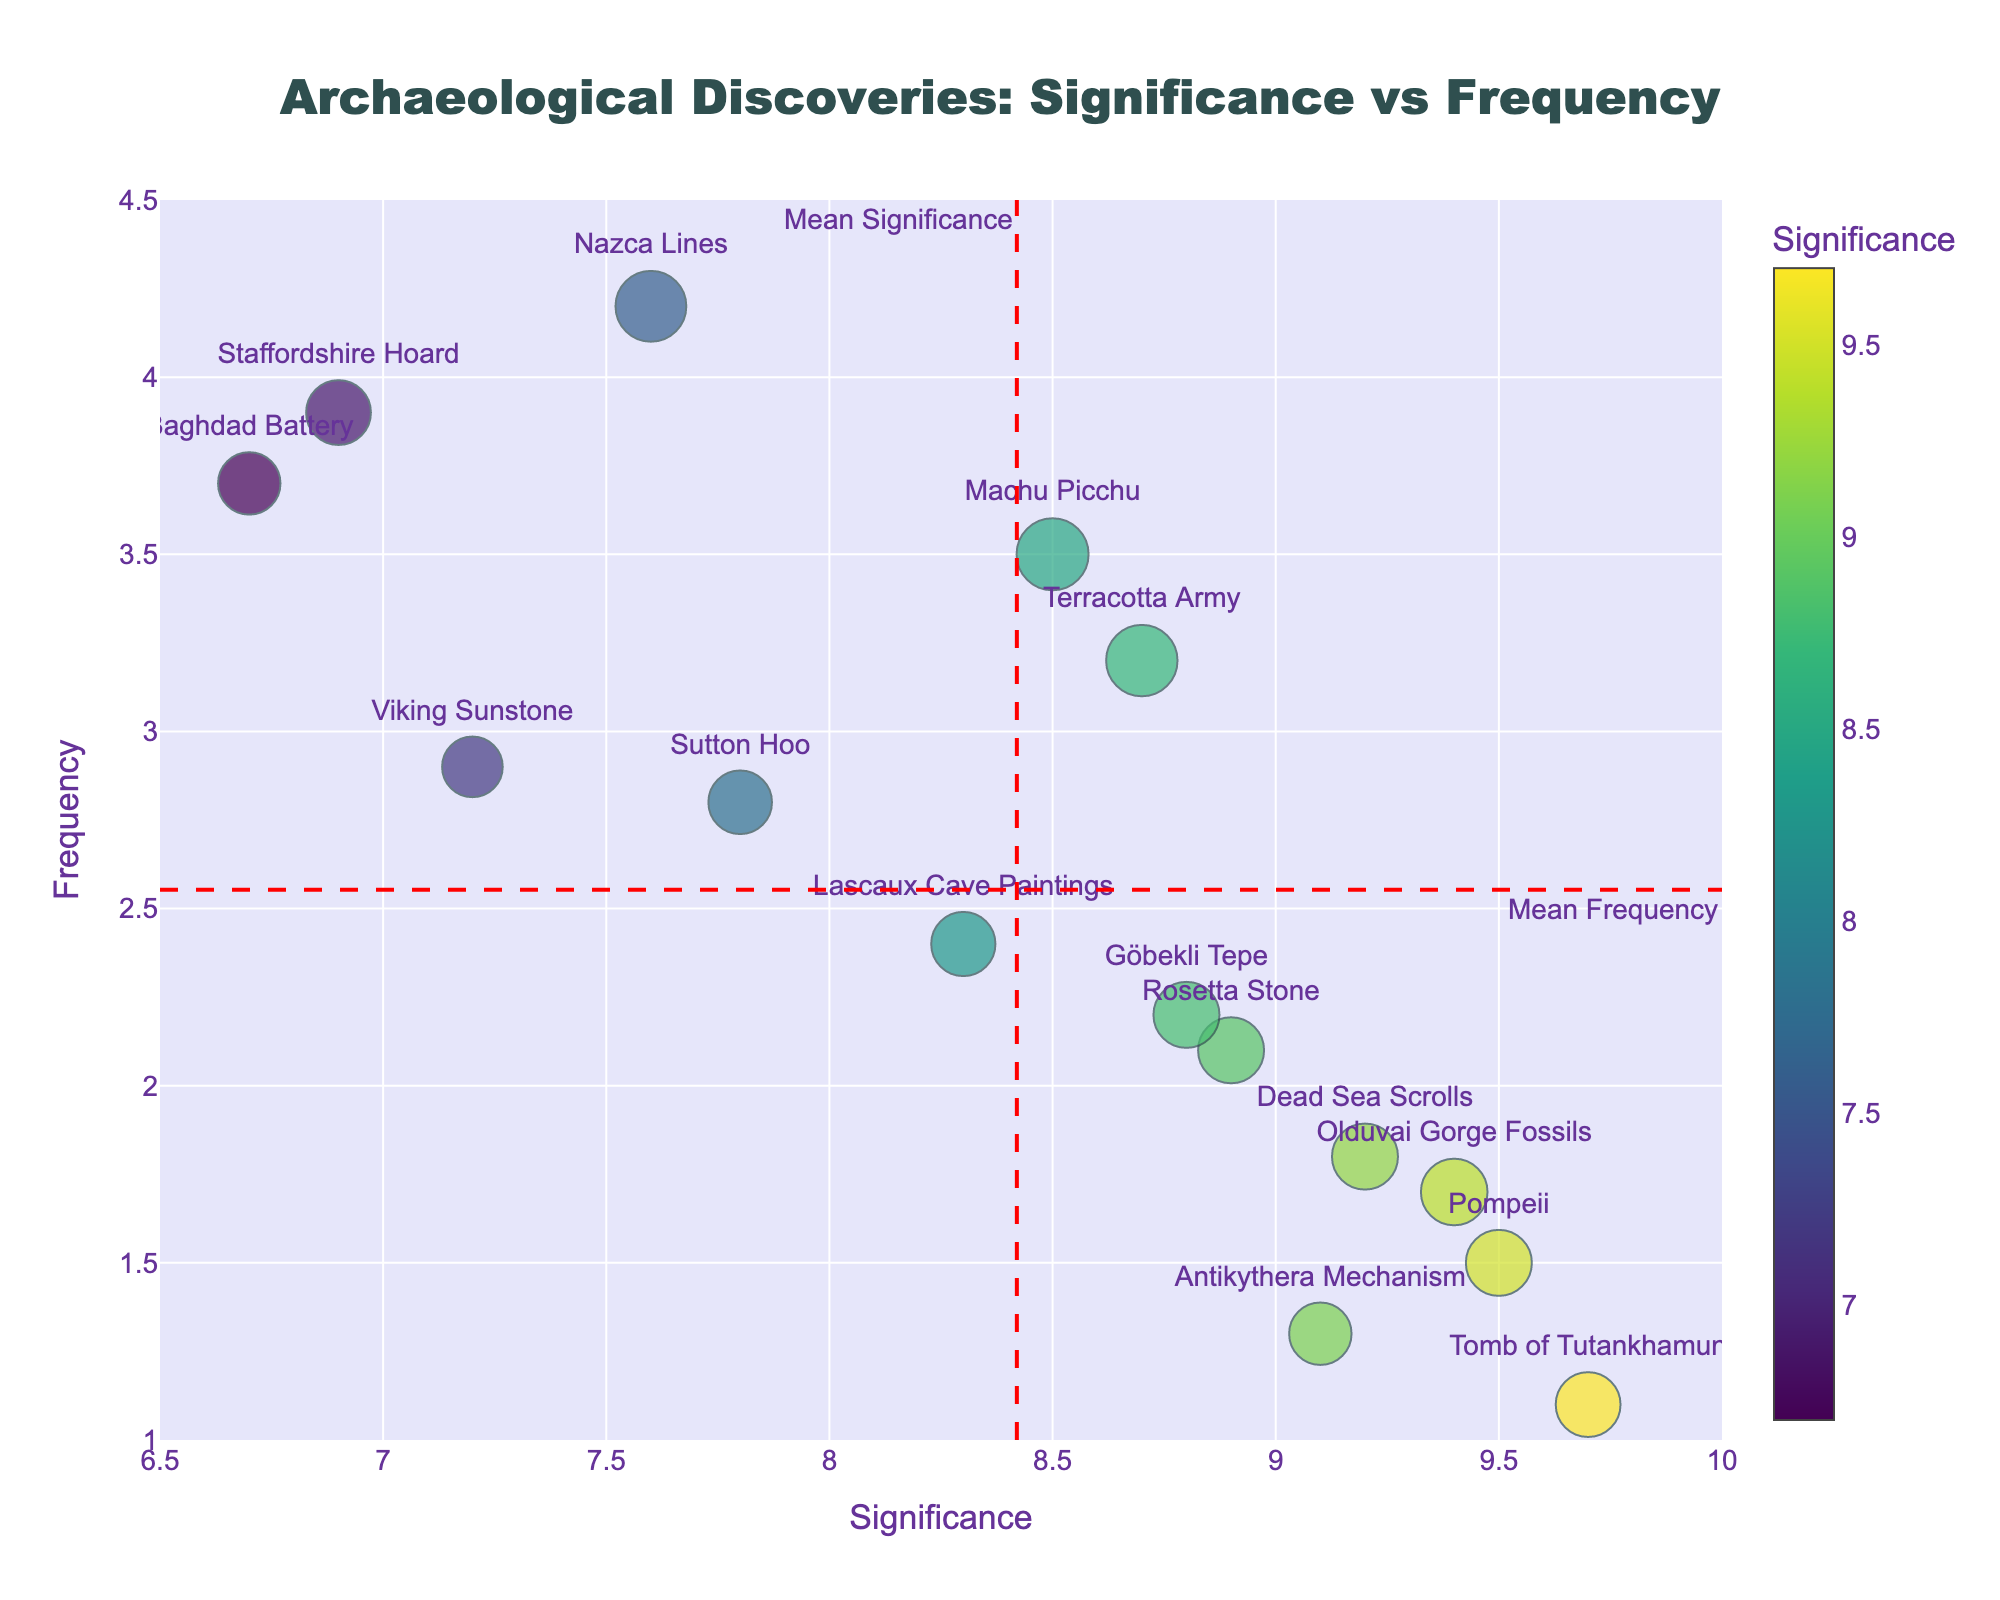What is the mean significance value across all discoveries? The mean significance value can be determined by the red vertical dashed line labeled "Mean Significance" in the plot.
Answer: 8.4 How many discoveries have a frequency higher than the mean frequency? To answer this, count the number of data points that are above the red horizontal dashed line labeled "Mean Frequency" on the plot.
Answer: 6 Which discovery has the highest significance value? By looking at the plot for the data point that is furthest to the right along the x-axis (Significance), we can see that it is the Tomb of Tutankhamun.
Answer: Tomb of Tutankhamun Which discovery is represented by the marker with the largest size? Marker size in the plot is determined by the combined significance and frequency values. The marker representing the Nazca Lines appears largest.
Answer: Nazca Lines What is the historical period for the discovery with the highest significance value? Look at the discovery with the highest significance value (Tomb of Tutankhamun) and check the hover text or reference data to find its historical period.
Answer: Ancient Egypt Are there any discoveries from the Anglo-Saxon England period with below-average significance? Identify the data points labeled as "Anglo-Saxon England" and check if their x-coordinate (Significance) is below the red vertical dashed line. Both Sutton Hoo and Staffordshire Hoard fall below the average significance value.
Answer: Yes What is the relationship between significance and frequency for the Pompeii discovery? Look at the coordinates of Pompeii on the plot. Its significance is high, and its frequency is low.
Answer: High significance, low frequency Which discoveries have both significance and frequency below their respective mean values? Identify the data points positioned to the left of the mean significance line and below the mean frequency line. The discoveries that fit this criterion are Staffordshire Hoard and Antikythera Mechanism.
Answer: Staffordshire Hoard, Antikythera Mechanism Do any discoveries from Ancient Rome appear above the mean significance line? Locate the data points labeled "Ancient Rome" and check if they are to the right of the red vertical dashed line.
Answer: No 